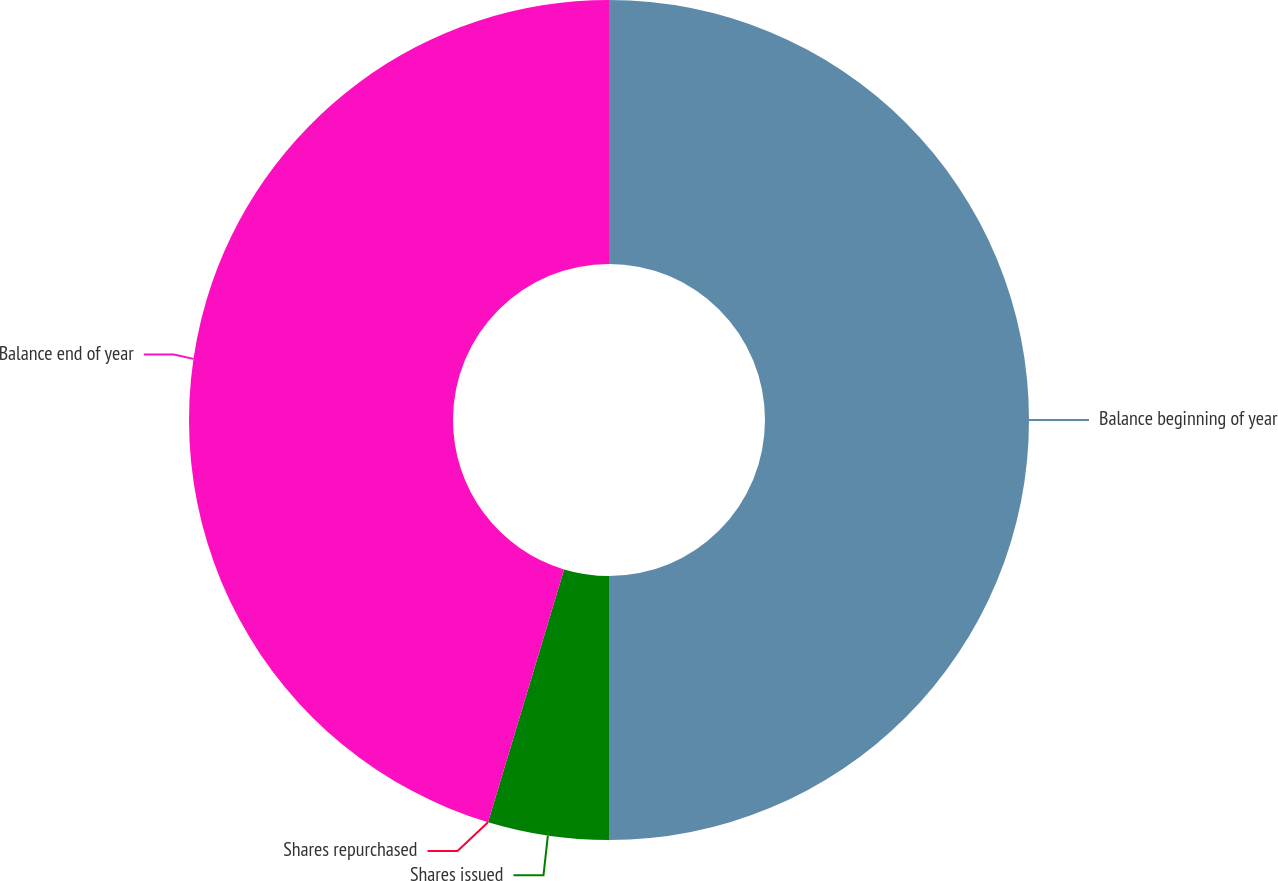Convert chart to OTSL. <chart><loc_0><loc_0><loc_500><loc_500><pie_chart><fcel>Balance beginning of year<fcel>Shares issued<fcel>Shares repurchased<fcel>Balance end of year<nl><fcel>50.0%<fcel>4.65%<fcel>0.0%<fcel>45.35%<nl></chart> 